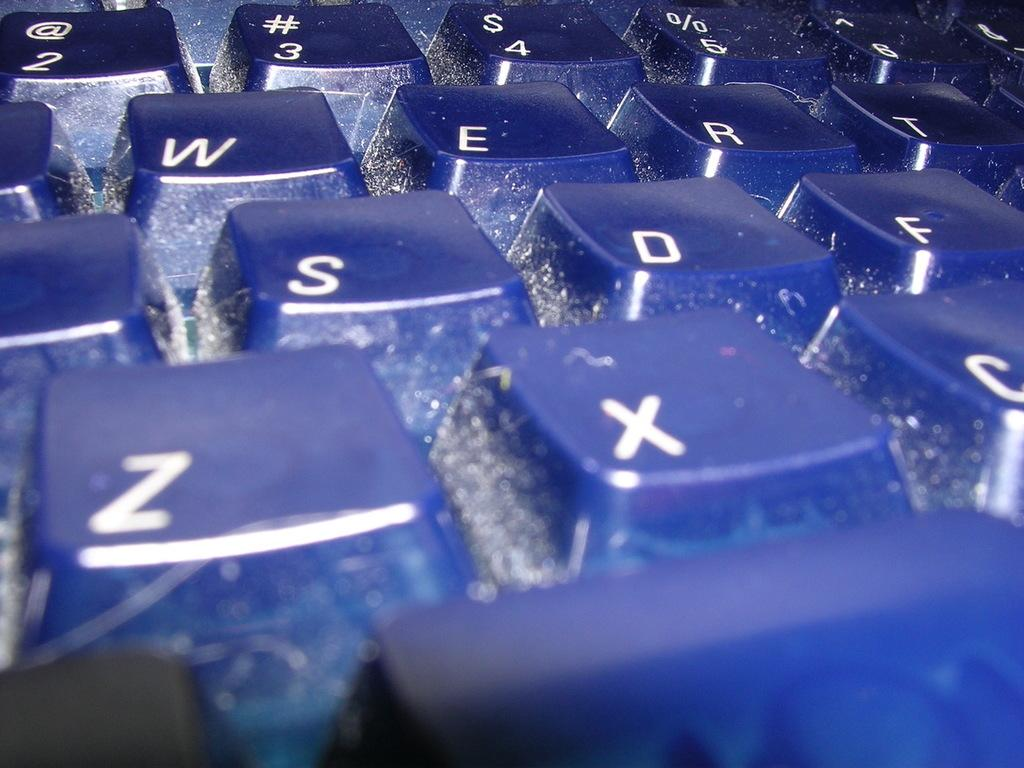Provide a one-sentence caption for the provided image. A close up of blue keys including the Z and X keys. 